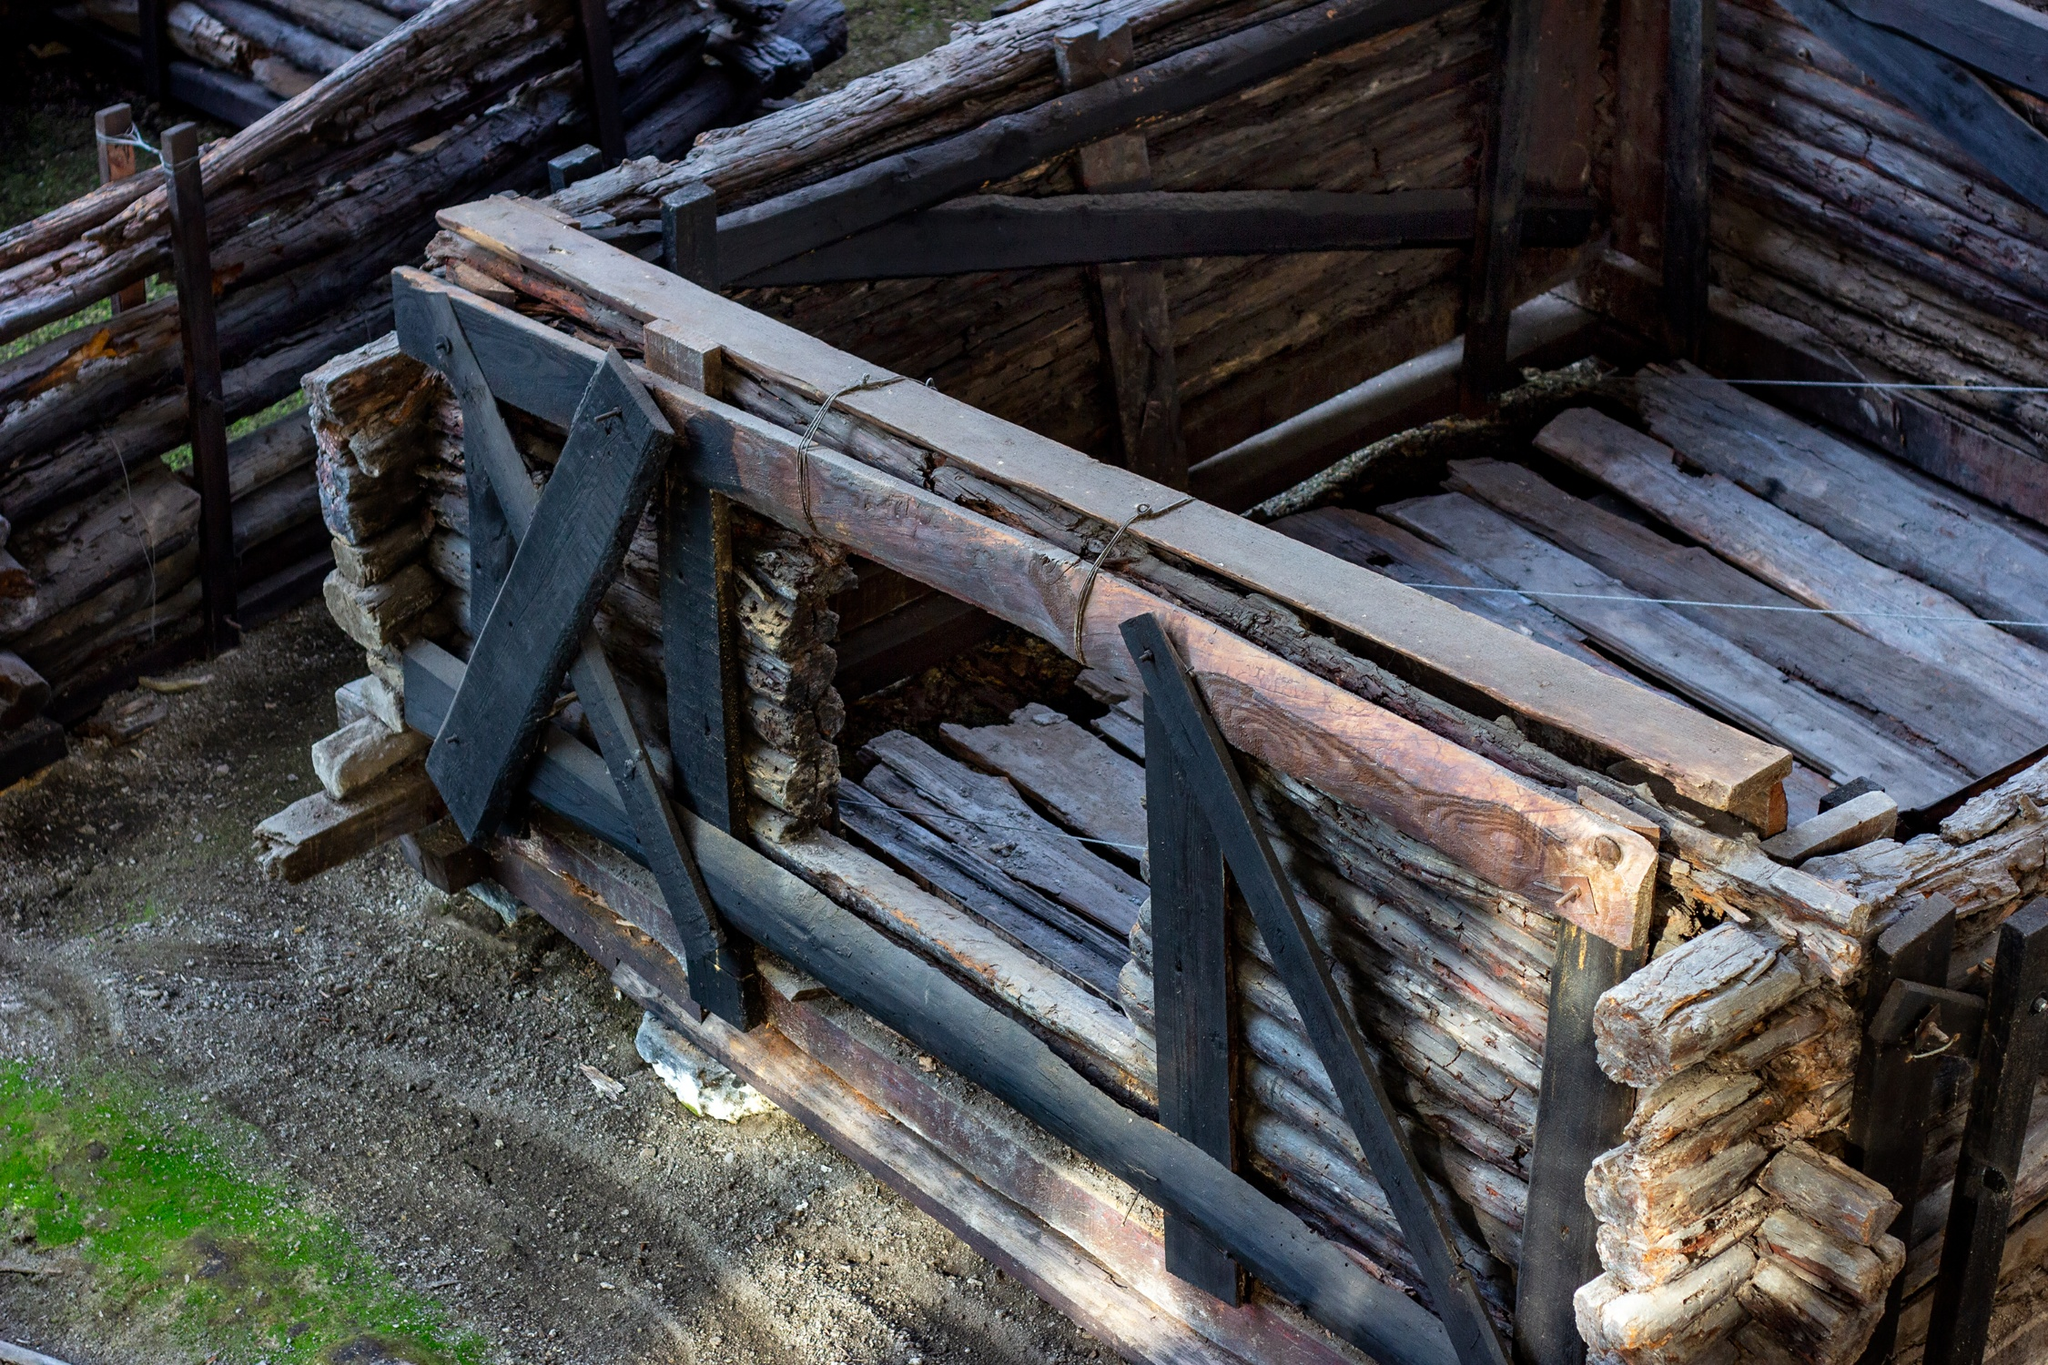Can you guess how old this bridge might be and what factors contribute to its weathered look? Judging by the extensive moss growth and the deeply grooved wood, the bridge could be several decades old. The weathered look is primarily due to exposure to moisture and the natural decay processes in a forested environment, which accelerate the aging of wood. The absence of contemporary construction materials suggests that it might be a historic structure, possibly maintained for heritage or aesthetic reasons rather than modern use. 